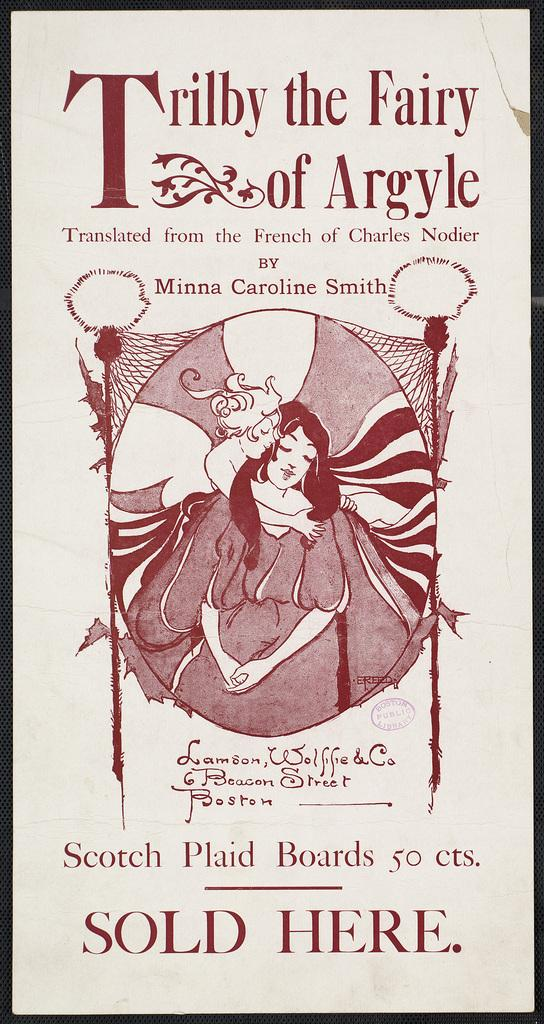Provide a one-sentence caption for the provided image. An old advertisement says that scotch plaid boards are sold there. 